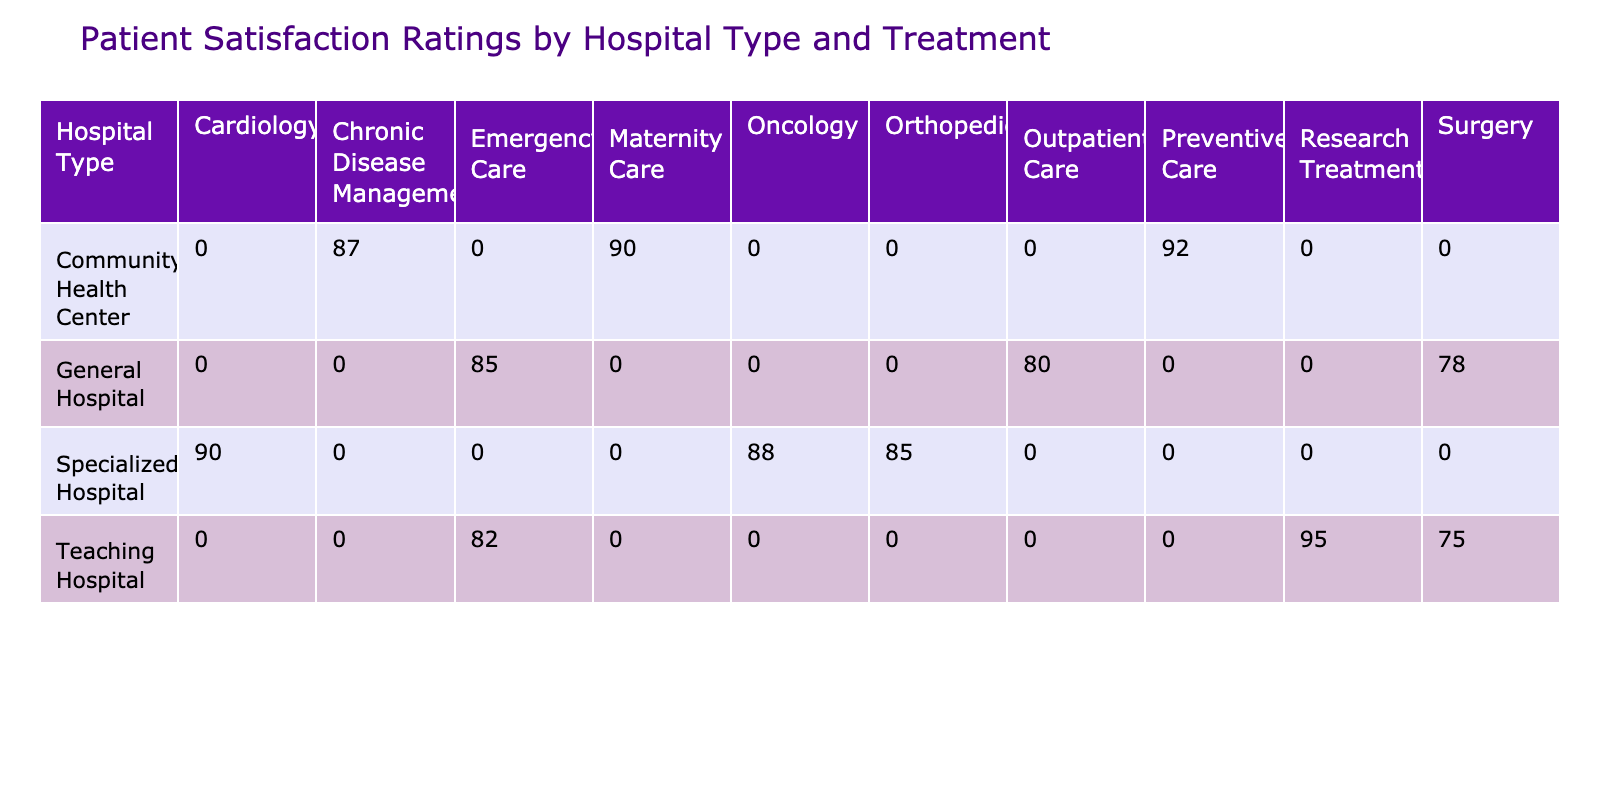What is the highest patient satisfaction rating for Specialized Hospitals? The satisfaction ratings for Specialized Hospitals are as follows: Cardiology (90), Orthopedics (85), and Oncology (88). The highest rating among these is 90 from Cardiology.
Answer: 90 What treatment type received the lowest satisfaction rating at Teaching Hospitals? The satisfaction ratings for treatments at Teaching Hospitals are: Emergency Care (82), Surgery (75), and Research Treatment (95). The lowest rating is 75 from Surgery.
Answer: 75 Is the average satisfaction rating for Community Health Center higher than that for General Hospitals? The average satisfaction rating for Community Health Center is (92 + 87 + 90) / 3 = 89.67, and for General Hospitals it is (85 + 78 + 80) / 3 = 81. The Community Health Center has a higher average satisfaction rating of 89.67 compared to 81.
Answer: Yes What is the difference between the highest and lowest satisfaction ratings for Emergency Care across hospital types? The highest rating for Emergency Care is 85 at General Hospital and the lowest is 82 at Teaching Hospital. The difference is 85 - 82 = 3.
Answer: 3 Are the satisfaction ratings for Oncology and Chronic Disease Management equal? The satisfaction rating for Oncology is 88, while for Chronic Disease Management, it is 87. They are not equal.
Answer: No What treatment at Specialized Hospitals had a higher satisfaction rating, Orthopedics or Oncology? Orthopedics has a satisfaction rating of 85 and Oncology has a rating of 88. Since 88 is greater than 85, Oncology has a higher rating.
Answer: Oncology Which hospital type had the best satisfaction rating for Outpatient Care? The table shows that only General Hospitals offer Outpatient Care with a satisfaction rating of 80. Since no other hospital type offers this treatment, General Hospitals has the best rating.
Answer: 80 What is the total satisfaction rating from all treatments received in General Hospitals? The satisfaction ratings for General Hospitals are: Emergency Care (85), Surgery (78), and Outpatient Care (80). The total satisfaction rating is 85 + 78 + 80 = 243.
Answer: 243 What treatment type had the highest satisfaction rating overall? The maximum satisfaction ratings from each treatment across all hospital types are: Emergency Care (85), Surgery (78), Outpatient Care (80), Cardiology (90), Orthopedics (85), Oncology (88), Preventive Care (92), Chronic Disease Management (87), Maternity Care (90), Research Treatment (95). The highest is 95 from Research Treatment.
Answer: 95 